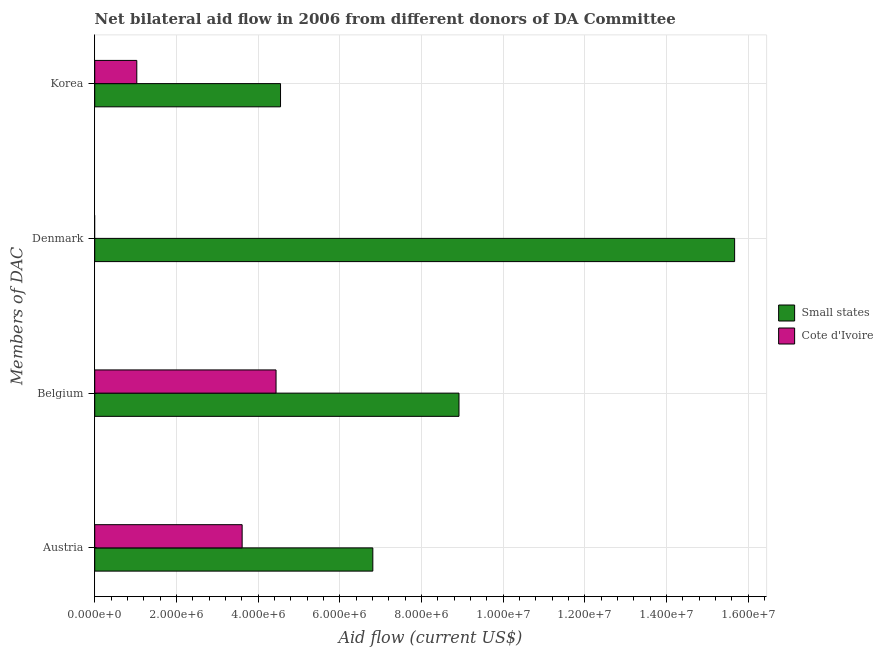How many different coloured bars are there?
Keep it short and to the point. 2. How many bars are there on the 4th tick from the top?
Provide a short and direct response. 2. What is the label of the 1st group of bars from the top?
Provide a short and direct response. Korea. What is the amount of aid given by austria in Cote d'Ivoire?
Ensure brevity in your answer.  3.61e+06. Across all countries, what is the maximum amount of aid given by korea?
Ensure brevity in your answer.  4.55e+06. Across all countries, what is the minimum amount of aid given by austria?
Your answer should be very brief. 3.61e+06. In which country was the amount of aid given by austria maximum?
Provide a succinct answer. Small states. What is the total amount of aid given by denmark in the graph?
Ensure brevity in your answer.  1.57e+07. What is the difference between the amount of aid given by belgium in Small states and that in Cote d'Ivoire?
Your answer should be compact. 4.48e+06. What is the difference between the amount of aid given by denmark in Cote d'Ivoire and the amount of aid given by belgium in Small states?
Your answer should be compact. -8.92e+06. What is the average amount of aid given by korea per country?
Provide a short and direct response. 2.79e+06. What is the difference between the amount of aid given by korea and amount of aid given by belgium in Small states?
Give a very brief answer. -4.37e+06. What is the ratio of the amount of aid given by austria in Cote d'Ivoire to that in Small states?
Offer a very short reply. 0.53. Is the amount of aid given by austria in Cote d'Ivoire less than that in Small states?
Offer a very short reply. Yes. What is the difference between the highest and the second highest amount of aid given by korea?
Your answer should be compact. 3.52e+06. What is the difference between the highest and the lowest amount of aid given by korea?
Give a very brief answer. 3.52e+06. In how many countries, is the amount of aid given by korea greater than the average amount of aid given by korea taken over all countries?
Your response must be concise. 1. Is it the case that in every country, the sum of the amount of aid given by belgium and amount of aid given by denmark is greater than the sum of amount of aid given by korea and amount of aid given by austria?
Ensure brevity in your answer.  No. Is it the case that in every country, the sum of the amount of aid given by austria and amount of aid given by belgium is greater than the amount of aid given by denmark?
Your response must be concise. Yes. How many countries are there in the graph?
Offer a terse response. 2. What is the difference between two consecutive major ticks on the X-axis?
Keep it short and to the point. 2.00e+06. Are the values on the major ticks of X-axis written in scientific E-notation?
Offer a terse response. Yes. Does the graph contain any zero values?
Ensure brevity in your answer.  Yes. Does the graph contain grids?
Offer a terse response. Yes. How are the legend labels stacked?
Make the answer very short. Vertical. What is the title of the graph?
Offer a terse response. Net bilateral aid flow in 2006 from different donors of DA Committee. Does "Palau" appear as one of the legend labels in the graph?
Ensure brevity in your answer.  No. What is the label or title of the Y-axis?
Provide a short and direct response. Members of DAC. What is the Aid flow (current US$) in Small states in Austria?
Ensure brevity in your answer.  6.81e+06. What is the Aid flow (current US$) of Cote d'Ivoire in Austria?
Ensure brevity in your answer.  3.61e+06. What is the Aid flow (current US$) of Small states in Belgium?
Make the answer very short. 8.92e+06. What is the Aid flow (current US$) of Cote d'Ivoire in Belgium?
Provide a short and direct response. 4.44e+06. What is the Aid flow (current US$) of Small states in Denmark?
Offer a terse response. 1.57e+07. What is the Aid flow (current US$) in Small states in Korea?
Ensure brevity in your answer.  4.55e+06. What is the Aid flow (current US$) of Cote d'Ivoire in Korea?
Provide a succinct answer. 1.03e+06. Across all Members of DAC, what is the maximum Aid flow (current US$) of Small states?
Provide a succinct answer. 1.57e+07. Across all Members of DAC, what is the maximum Aid flow (current US$) in Cote d'Ivoire?
Provide a short and direct response. 4.44e+06. Across all Members of DAC, what is the minimum Aid flow (current US$) of Small states?
Your response must be concise. 4.55e+06. What is the total Aid flow (current US$) of Small states in the graph?
Ensure brevity in your answer.  3.60e+07. What is the total Aid flow (current US$) in Cote d'Ivoire in the graph?
Your answer should be very brief. 9.08e+06. What is the difference between the Aid flow (current US$) of Small states in Austria and that in Belgium?
Your answer should be very brief. -2.11e+06. What is the difference between the Aid flow (current US$) in Cote d'Ivoire in Austria and that in Belgium?
Your answer should be very brief. -8.30e+05. What is the difference between the Aid flow (current US$) in Small states in Austria and that in Denmark?
Keep it short and to the point. -8.86e+06. What is the difference between the Aid flow (current US$) of Small states in Austria and that in Korea?
Give a very brief answer. 2.26e+06. What is the difference between the Aid flow (current US$) in Cote d'Ivoire in Austria and that in Korea?
Offer a very short reply. 2.58e+06. What is the difference between the Aid flow (current US$) in Small states in Belgium and that in Denmark?
Keep it short and to the point. -6.75e+06. What is the difference between the Aid flow (current US$) of Small states in Belgium and that in Korea?
Your response must be concise. 4.37e+06. What is the difference between the Aid flow (current US$) in Cote d'Ivoire in Belgium and that in Korea?
Your answer should be compact. 3.41e+06. What is the difference between the Aid flow (current US$) of Small states in Denmark and that in Korea?
Provide a short and direct response. 1.11e+07. What is the difference between the Aid flow (current US$) of Small states in Austria and the Aid flow (current US$) of Cote d'Ivoire in Belgium?
Offer a terse response. 2.37e+06. What is the difference between the Aid flow (current US$) of Small states in Austria and the Aid flow (current US$) of Cote d'Ivoire in Korea?
Your response must be concise. 5.78e+06. What is the difference between the Aid flow (current US$) of Small states in Belgium and the Aid flow (current US$) of Cote d'Ivoire in Korea?
Keep it short and to the point. 7.89e+06. What is the difference between the Aid flow (current US$) of Small states in Denmark and the Aid flow (current US$) of Cote d'Ivoire in Korea?
Keep it short and to the point. 1.46e+07. What is the average Aid flow (current US$) in Small states per Members of DAC?
Make the answer very short. 8.99e+06. What is the average Aid flow (current US$) of Cote d'Ivoire per Members of DAC?
Provide a short and direct response. 2.27e+06. What is the difference between the Aid flow (current US$) in Small states and Aid flow (current US$) in Cote d'Ivoire in Austria?
Keep it short and to the point. 3.20e+06. What is the difference between the Aid flow (current US$) in Small states and Aid flow (current US$) in Cote d'Ivoire in Belgium?
Your answer should be very brief. 4.48e+06. What is the difference between the Aid flow (current US$) of Small states and Aid flow (current US$) of Cote d'Ivoire in Korea?
Keep it short and to the point. 3.52e+06. What is the ratio of the Aid flow (current US$) of Small states in Austria to that in Belgium?
Your response must be concise. 0.76. What is the ratio of the Aid flow (current US$) of Cote d'Ivoire in Austria to that in Belgium?
Make the answer very short. 0.81. What is the ratio of the Aid flow (current US$) in Small states in Austria to that in Denmark?
Your response must be concise. 0.43. What is the ratio of the Aid flow (current US$) in Small states in Austria to that in Korea?
Your answer should be compact. 1.5. What is the ratio of the Aid flow (current US$) in Cote d'Ivoire in Austria to that in Korea?
Ensure brevity in your answer.  3.5. What is the ratio of the Aid flow (current US$) of Small states in Belgium to that in Denmark?
Your response must be concise. 0.57. What is the ratio of the Aid flow (current US$) of Small states in Belgium to that in Korea?
Make the answer very short. 1.96. What is the ratio of the Aid flow (current US$) in Cote d'Ivoire in Belgium to that in Korea?
Your answer should be compact. 4.31. What is the ratio of the Aid flow (current US$) of Small states in Denmark to that in Korea?
Keep it short and to the point. 3.44. What is the difference between the highest and the second highest Aid flow (current US$) of Small states?
Ensure brevity in your answer.  6.75e+06. What is the difference between the highest and the second highest Aid flow (current US$) of Cote d'Ivoire?
Your answer should be compact. 8.30e+05. What is the difference between the highest and the lowest Aid flow (current US$) of Small states?
Your answer should be compact. 1.11e+07. What is the difference between the highest and the lowest Aid flow (current US$) of Cote d'Ivoire?
Provide a succinct answer. 4.44e+06. 